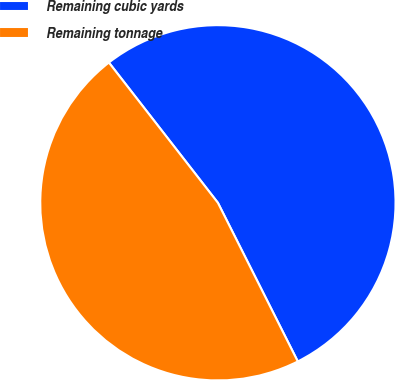Convert chart to OTSL. <chart><loc_0><loc_0><loc_500><loc_500><pie_chart><fcel>Remaining cubic yards<fcel>Remaining tonnage<nl><fcel>53.09%<fcel>46.91%<nl></chart> 